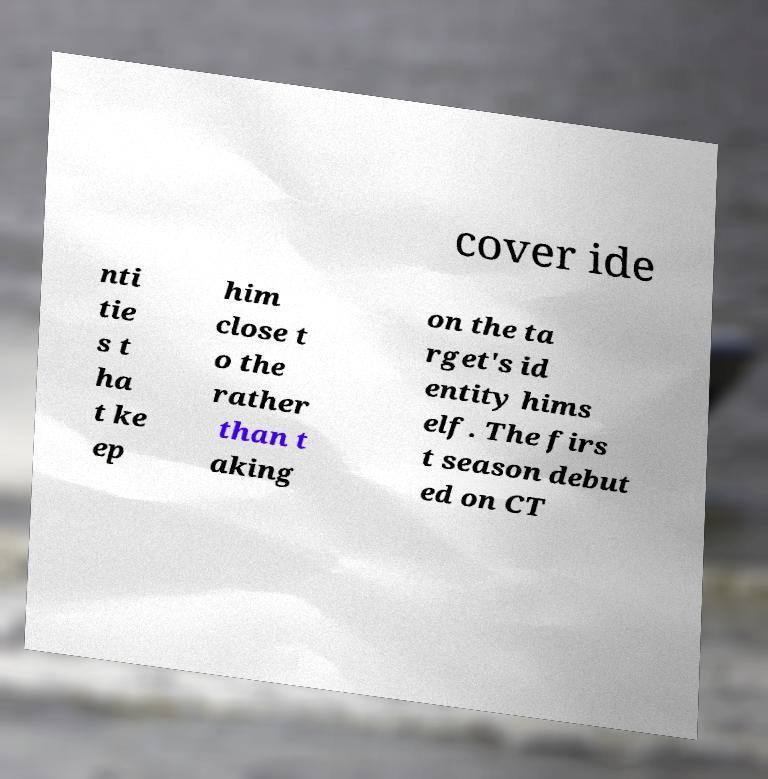For documentation purposes, I need the text within this image transcribed. Could you provide that? cover ide nti tie s t ha t ke ep him close t o the rather than t aking on the ta rget's id entity hims elf. The firs t season debut ed on CT 